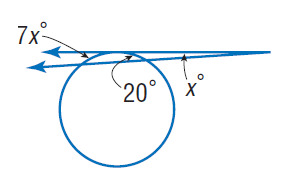Question: Find x. Assume that any segment that appears to be tangent is tangent.
Choices:
A. 4
B. 7
C. 20
D. 28
Answer with the letter. Answer: A 